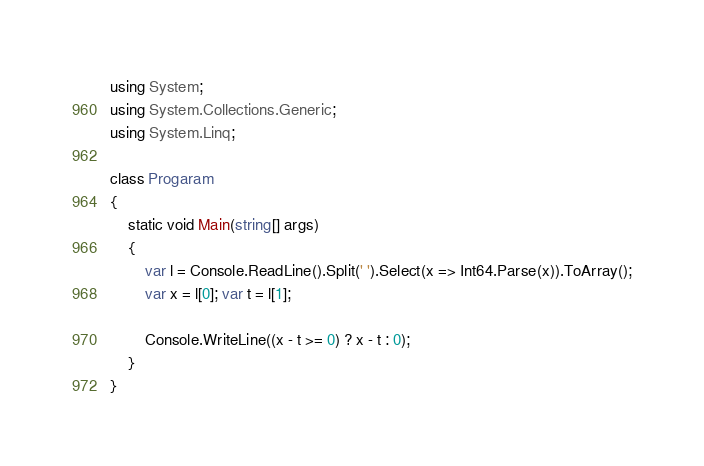<code> <loc_0><loc_0><loc_500><loc_500><_C#_>using System;
using System.Collections.Generic;
using System.Linq;

class Progaram
{
    static void Main(string[] args)
    {
        var l = Console.ReadLine().Split(' ').Select(x => Int64.Parse(x)).ToArray();
        var x = l[0]; var t = l[1];

        Console.WriteLine((x - t >= 0) ? x - t : 0);
    }
}
</code> 